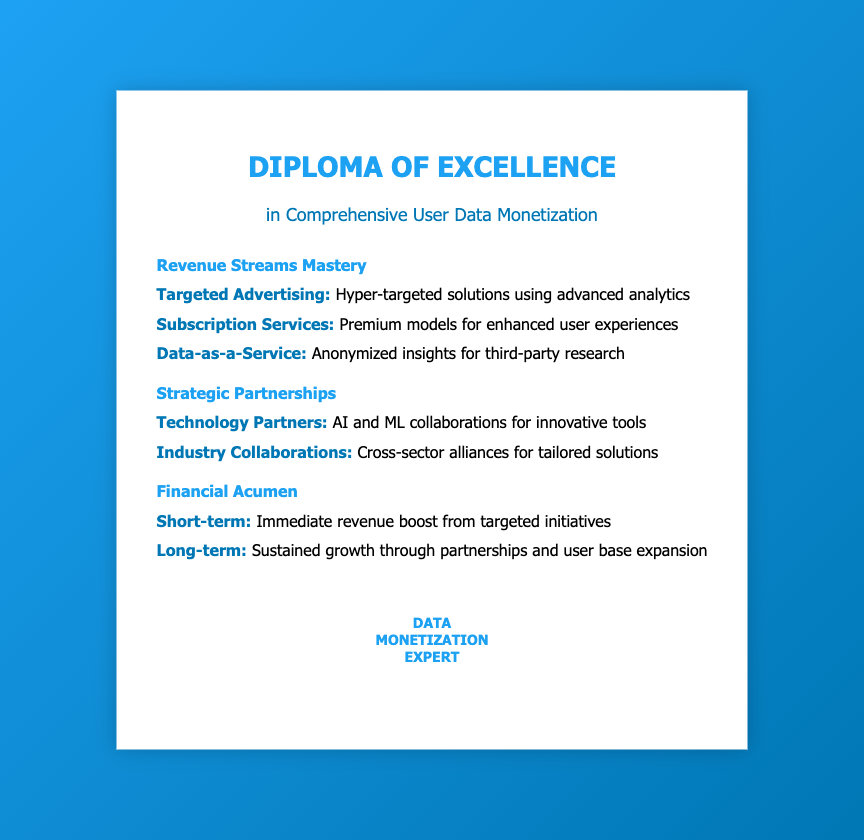what is the title of the diploma? The title is prominently displayed at the top of the document, which is "Diploma of Excellence."
Answer: Diploma of Excellence what is the subtitle of the diploma? The subtitle provides more detail about the diploma's focus area, which is "in Comprehensive User Data Monetization."
Answer: in Comprehensive User Data Monetization name one revenue stream mentioned in the document. The document lists different revenue streams; one of them is "Targeted Advertising."
Answer: Targeted Advertising what type of partnerships are suggested in the document? The document includes suggestions for partnerships; one example is "Technology Partners."
Answer: Technology Partners what is the focus area of the financial acumen section? The section focuses on two timeframes for revenue; one of them is "Short-term."
Answer: Short-term how does the diploma describe the long-term financial outcome? The document mentions a sustained approach to finances, described as "Sustained growth through partnerships and user base expansion."
Answer: Sustained growth through partnerships and user base expansion what is emphasized regarding subscription services? The document emphasizes that subscription services aim to provide "Premium models for enhanced user experiences."
Answer: Premium models for enhanced user experiences how many sections are present in the content of the diploma? The content of the diploma is divided into three distinct sections, which are "Revenue Streams Mastery," "Strategic Partnerships," and "Financial Acumen."
Answer: Three what is the seal's label on the diploma? The seal at the bottom center of the document has the label indicating expertise, which is "Data Monetization Expert."
Answer: Data Monetization Expert 